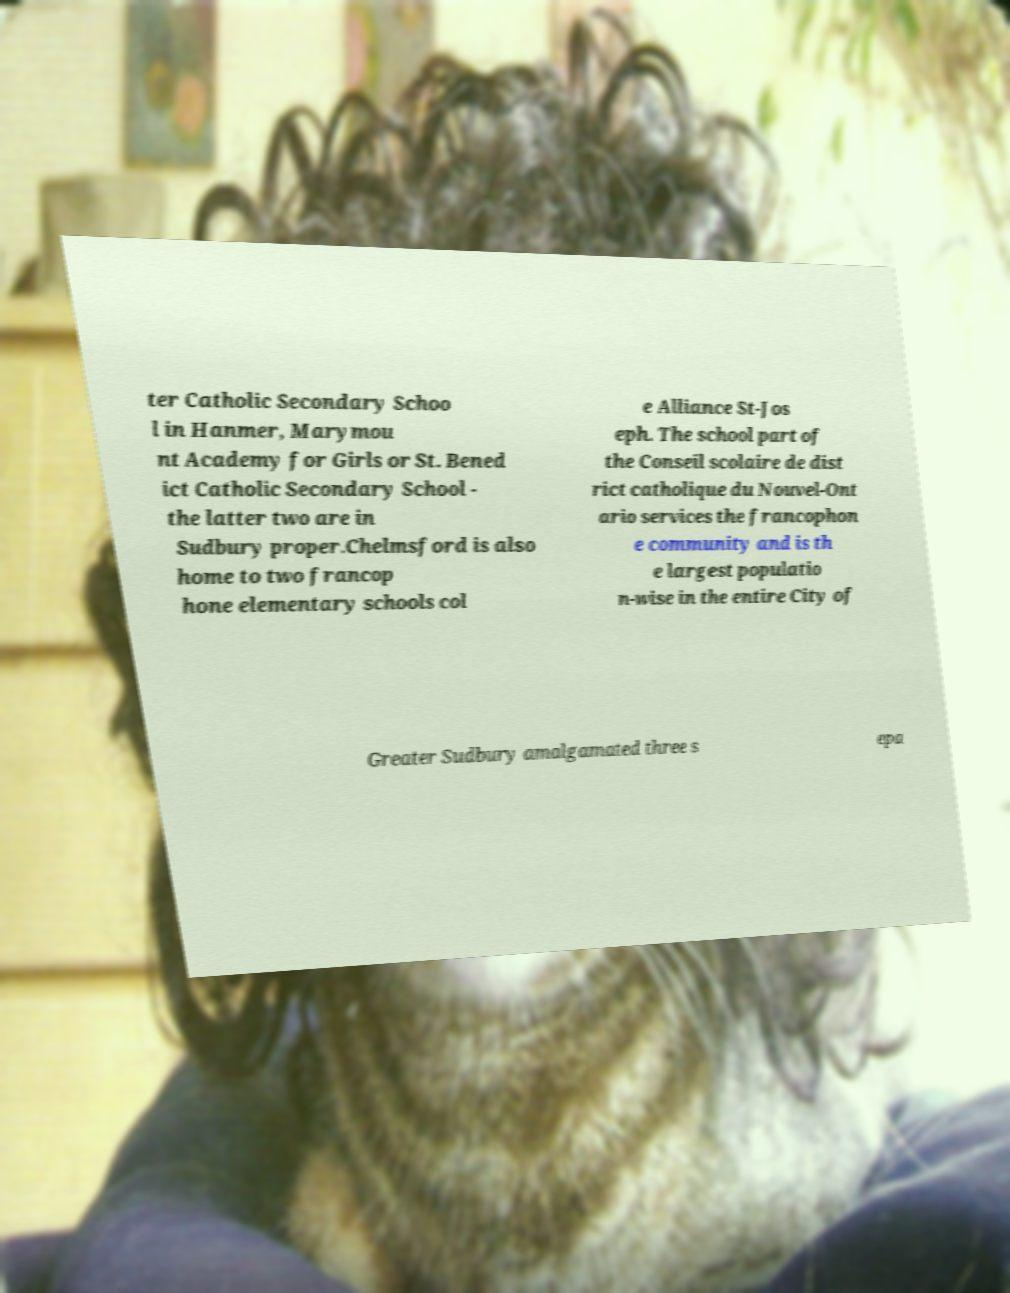Can you read and provide the text displayed in the image?This photo seems to have some interesting text. Can you extract and type it out for me? ter Catholic Secondary Schoo l in Hanmer, Marymou nt Academy for Girls or St. Bened ict Catholic Secondary School - the latter two are in Sudbury proper.Chelmsford is also home to two francop hone elementary schools col e Alliance St-Jos eph. The school part of the Conseil scolaire de dist rict catholique du Nouvel-Ont ario services the francophon e community and is th e largest populatio n-wise in the entire City of Greater Sudbury amalgamated three s epa 